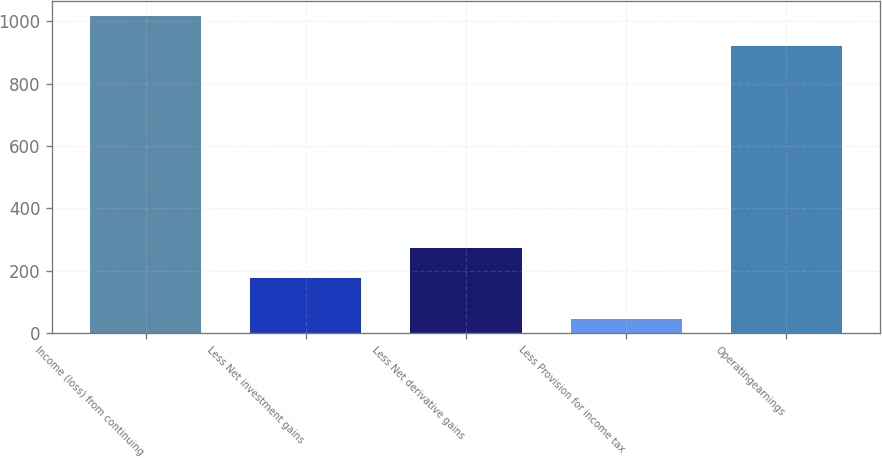Convert chart. <chart><loc_0><loc_0><loc_500><loc_500><bar_chart><fcel>Income (loss) from continuing<fcel>Less Net investment gains<fcel>Less Net derivative gains<fcel>Less Provision for income tax<fcel>Operatingearnings<nl><fcel>1015.8<fcel>176<fcel>271.8<fcel>44<fcel>920<nl></chart> 